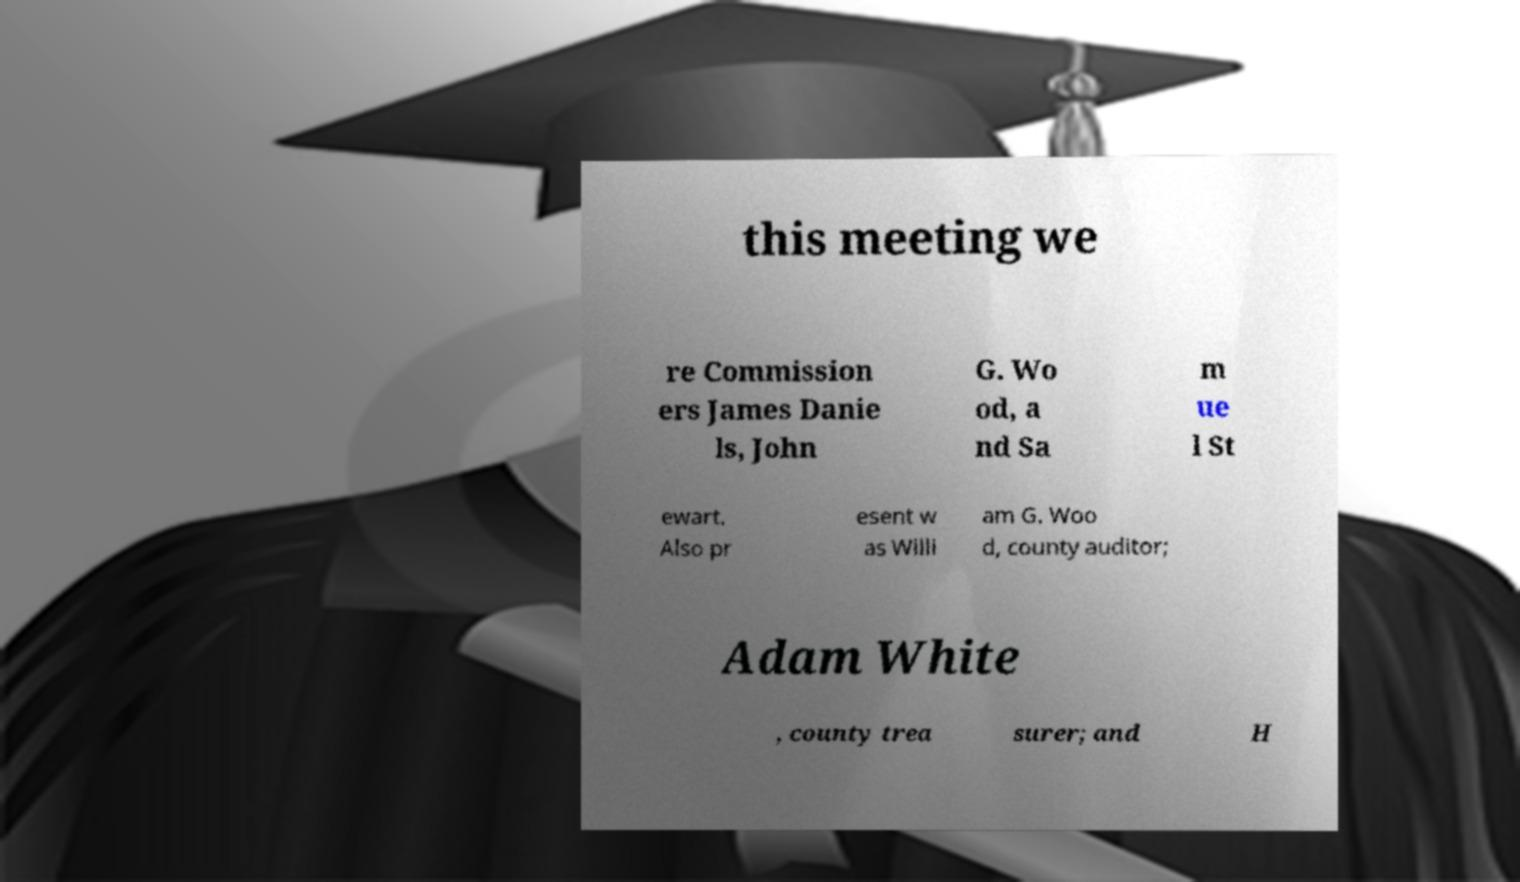For documentation purposes, I need the text within this image transcribed. Could you provide that? this meeting we re Commission ers James Danie ls, John G. Wo od, a nd Sa m ue l St ewart. Also pr esent w as Willi am G. Woo d, county auditor; Adam White , county trea surer; and H 